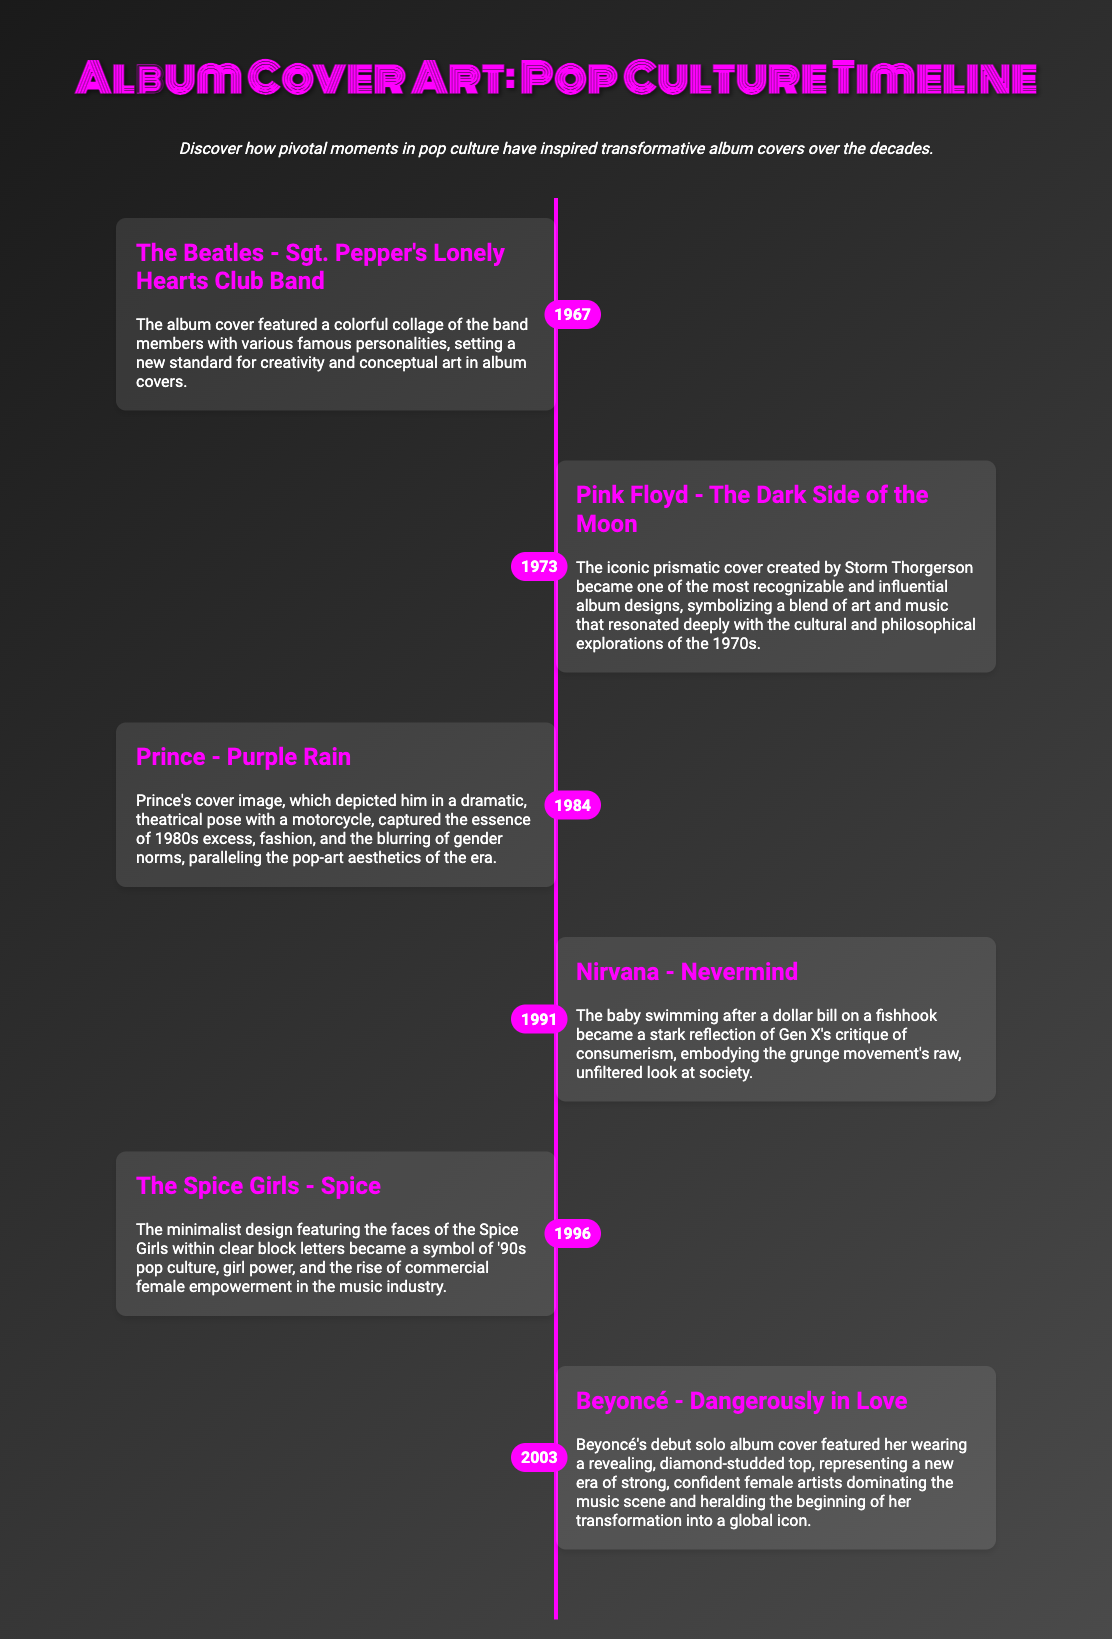What year was The Beatles' album released? The year is specified in the timeline next to The Beatles - Sgt. Pepper's Lonely Hearts Club Band entry.
Answer: 1967 Who created the cover for Pink Floyd's "The Dark Side of the Moon"? The document mentions Storm Thorgerson as the creator of the iconic prismatic cover.
Answer: Storm Thorgerson What significant theme does Nirvana's "Nevermind" cover reflect? The cover's imagery reflects a critique of consumerism as noted in the description.
Answer: Consumerism What was the cultural representation of Prince's cover for "Purple Rain"? The description highlights 1980s excess, fashion, and the blurring of gender norms as significant aspects.
Answer: 1980s excess Which girl group's album cover symbolizes '90s pop culture? The event highlights The Spice Girls' album with specific cultural implications outlined in the description.
Answer: The Spice Girls How many albums are referenced in the timeline? The timeline lists six different albums/events in total.
Answer: Six What color is associated with the timeline's design? The design features a gradient background along with prominent pink accents in the timeline.
Answer: Pink Who is depicted on Beyoncé's solo album cover? The description states that Beyoncé is featured in a revealing, diamond-studded top on her cover.
Answer: Beyoncé 